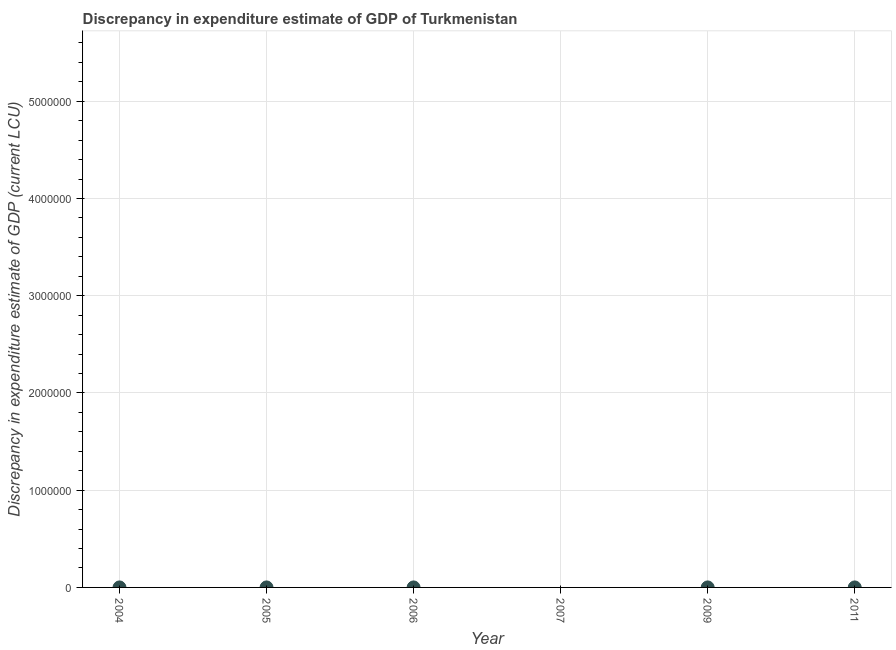What is the discrepancy in expenditure estimate of gdp in 2006?
Keep it short and to the point. 9.91e-5. Across all years, what is the maximum discrepancy in expenditure estimate of gdp?
Your answer should be very brief. 0. In which year was the discrepancy in expenditure estimate of gdp maximum?
Give a very brief answer. 2004. What is the sum of the discrepancy in expenditure estimate of gdp?
Keep it short and to the point. 0. What is the difference between the discrepancy in expenditure estimate of gdp in 2004 and 2009?
Make the answer very short. 1.0999999999999996e-6. What is the average discrepancy in expenditure estimate of gdp per year?
Offer a terse response. 6.604999999999999e-5. What is the median discrepancy in expenditure estimate of gdp?
Your answer should be very brief. 9.83e-5. What is the ratio of the discrepancy in expenditure estimate of gdp in 2004 to that in 2009?
Ensure brevity in your answer.  1.01. Is the discrepancy in expenditure estimate of gdp in 2005 less than that in 2011?
Your response must be concise. Yes. Is the difference between the discrepancy in expenditure estimate of gdp in 2004 and 2009 greater than the difference between any two years?
Give a very brief answer. No. What is the difference between the highest and the second highest discrepancy in expenditure estimate of gdp?
Make the answer very short. 9.999999999999972e-7. What is the difference between the highest and the lowest discrepancy in expenditure estimate of gdp?
Provide a succinct answer. 0. In how many years, is the discrepancy in expenditure estimate of gdp greater than the average discrepancy in expenditure estimate of gdp taken over all years?
Make the answer very short. 4. What is the difference between two consecutive major ticks on the Y-axis?
Keep it short and to the point. 1.00e+06. Does the graph contain grids?
Offer a terse response. Yes. What is the title of the graph?
Provide a succinct answer. Discrepancy in expenditure estimate of GDP of Turkmenistan. What is the label or title of the Y-axis?
Provide a succinct answer. Discrepancy in expenditure estimate of GDP (current LCU). What is the Discrepancy in expenditure estimate of GDP (current LCU) in 2004?
Make the answer very short. 0. What is the Discrepancy in expenditure estimate of GDP (current LCU) in 2005?
Make the answer very short. 5e-7. What is the Discrepancy in expenditure estimate of GDP (current LCU) in 2006?
Your response must be concise. 9.91e-5. What is the Discrepancy in expenditure estimate of GDP (current LCU) in 2007?
Offer a very short reply. 0. What is the Discrepancy in expenditure estimate of GDP (current LCU) in 2009?
Your answer should be compact. 9.9e-5. What is the Discrepancy in expenditure estimate of GDP (current LCU) in 2011?
Make the answer very short. 9.76e-5. What is the difference between the Discrepancy in expenditure estimate of GDP (current LCU) in 2004 and 2009?
Give a very brief answer. 0. What is the difference between the Discrepancy in expenditure estimate of GDP (current LCU) in 2005 and 2006?
Keep it short and to the point. -0. What is the difference between the Discrepancy in expenditure estimate of GDP (current LCU) in 2005 and 2009?
Your answer should be compact. -0. What is the difference between the Discrepancy in expenditure estimate of GDP (current LCU) in 2005 and 2011?
Your response must be concise. -0. What is the difference between the Discrepancy in expenditure estimate of GDP (current LCU) in 2006 and 2009?
Offer a very short reply. 0. What is the difference between the Discrepancy in expenditure estimate of GDP (current LCU) in 2006 and 2011?
Provide a succinct answer. 0. What is the difference between the Discrepancy in expenditure estimate of GDP (current LCU) in 2009 and 2011?
Your answer should be compact. 0. What is the ratio of the Discrepancy in expenditure estimate of GDP (current LCU) in 2004 to that in 2005?
Offer a very short reply. 200.2. What is the ratio of the Discrepancy in expenditure estimate of GDP (current LCU) in 2004 to that in 2011?
Offer a very short reply. 1.03. What is the ratio of the Discrepancy in expenditure estimate of GDP (current LCU) in 2005 to that in 2006?
Ensure brevity in your answer.  0.01. What is the ratio of the Discrepancy in expenditure estimate of GDP (current LCU) in 2005 to that in 2009?
Offer a very short reply. 0.01. What is the ratio of the Discrepancy in expenditure estimate of GDP (current LCU) in 2005 to that in 2011?
Ensure brevity in your answer.  0.01. What is the ratio of the Discrepancy in expenditure estimate of GDP (current LCU) in 2009 to that in 2011?
Make the answer very short. 1.01. 